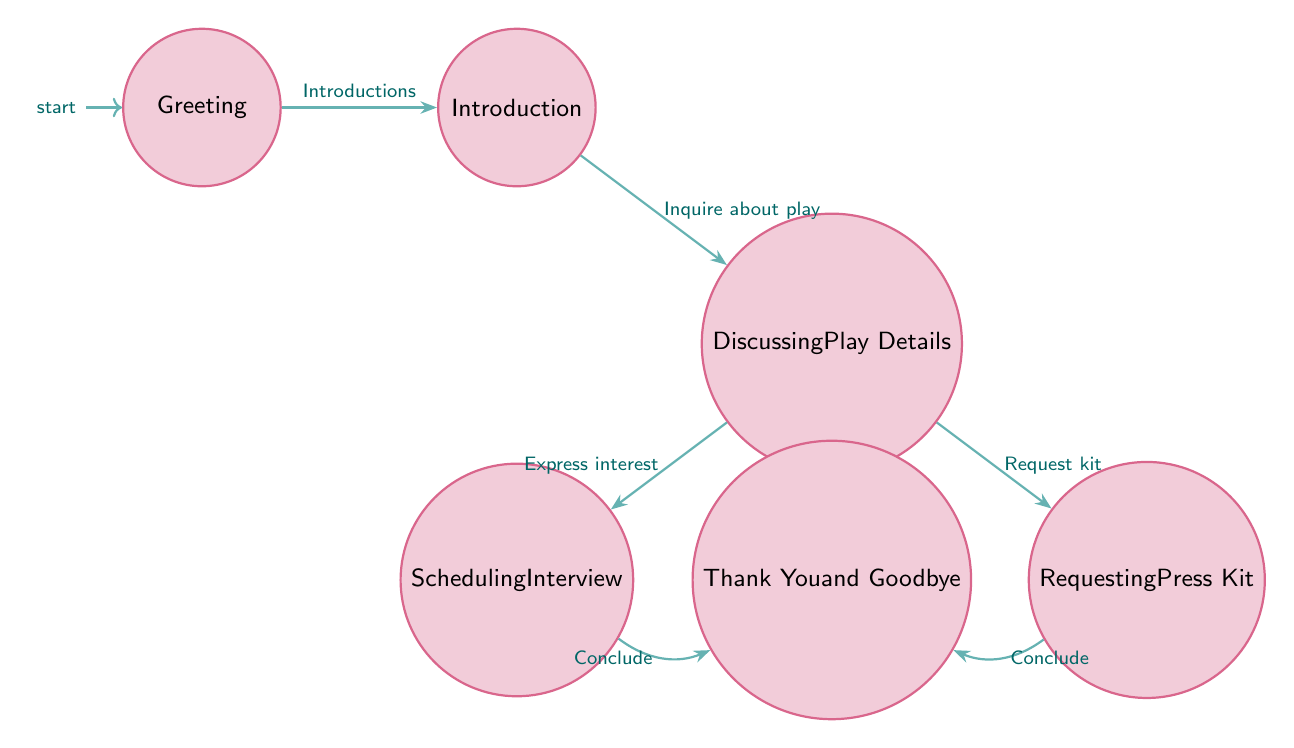What is the initial state of the interaction? The initial state is "Greeting," which is where the critic first greets the PR manager. This is indicated as the starting point in the diagram.
Answer: Greeting How many total states are present in the diagram? There are six states in total: Greeting, Introduction, Discussing Play Details, Scheduling Interview, Requesting Press Kit, and Thank You and Goodbye. This can be counted directly from the nodes listed in the diagram.
Answer: 6 What does the critic do after the Introduction state? After the Introduction state, the critic inquires about play details, transitioning to Discussing Play Details. This is shown by the edge connecting Introduction to Discussing Play Details.
Answer: Inquire about play What are the two options available after Discussing Play Details? The critic can either schedule an interview or request a press kit after Discussing Play Details, as represented by the two outgoing edges leading from this state.
Answer: Schedule interview or request kit What is the final state after scheduling an interview? After scheduling the interview in the Scheduling Interview state, the conversation concludes with the Thank You and Goodbye state, as indicated by the edge connecting these two states.
Answer: Thank You and Goodbye If the critic requests a press kit, what happens next? If a press kit is requested, the interaction moves to the Thank You and Goodbye state, as represented by the edge from Requesting Press Kit to Thank You and Goodbye.
Answer: Thank You and Goodbye Which states have transitions leading directly into Thank You and Goodbye? The states "Scheduling Interview" and "Requesting Press Kit" both have transitions leading into the Thank You and Goodbye state, shown by the edges connecting these states.
Answer: Scheduling Interview and Requesting Press Kit What is the relationship between Discussing Play Details and Introduction? The relationship is that the critic moves from Introduction to Discussing Play Details after inquiring about play details; this is shown by the directed edge connecting these two states.
Answer: Transition to Discussing Play Details 